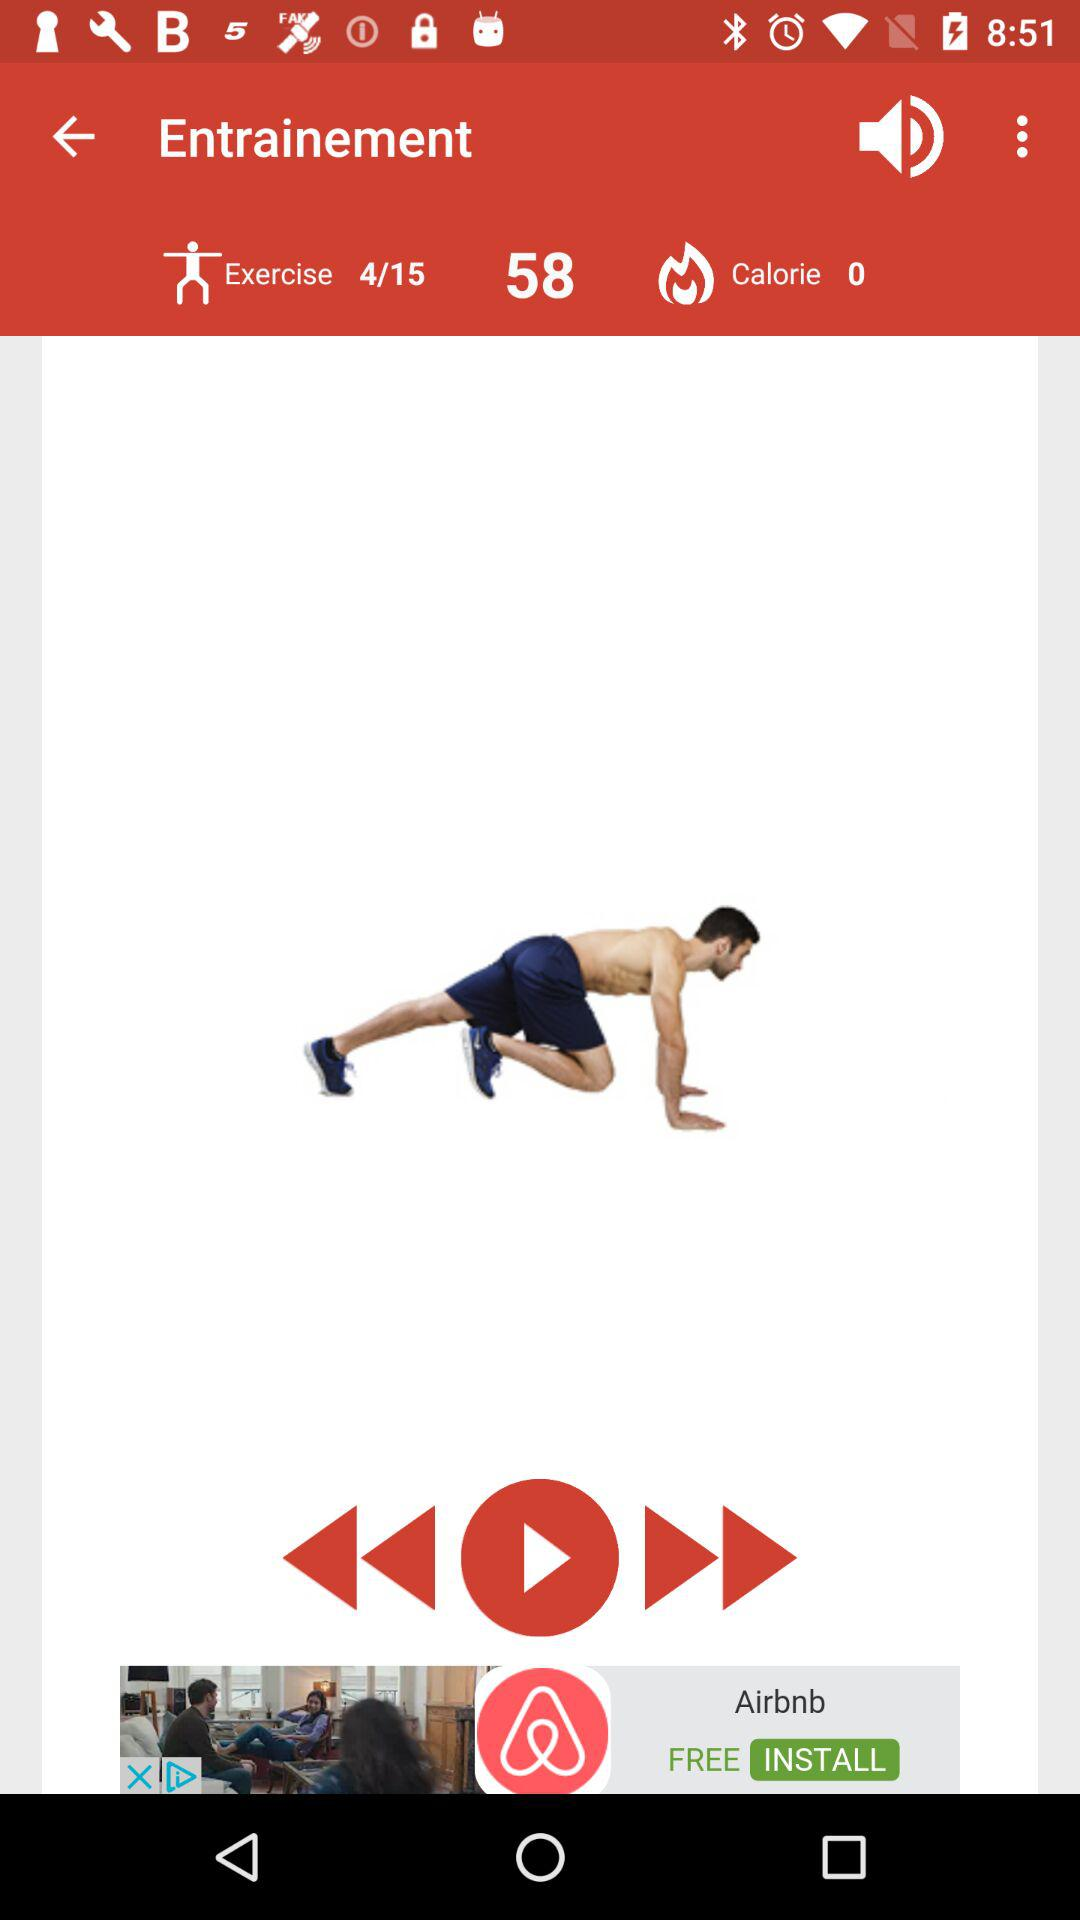How many calories have been burned?
Answer the question using a single word or phrase. 0 